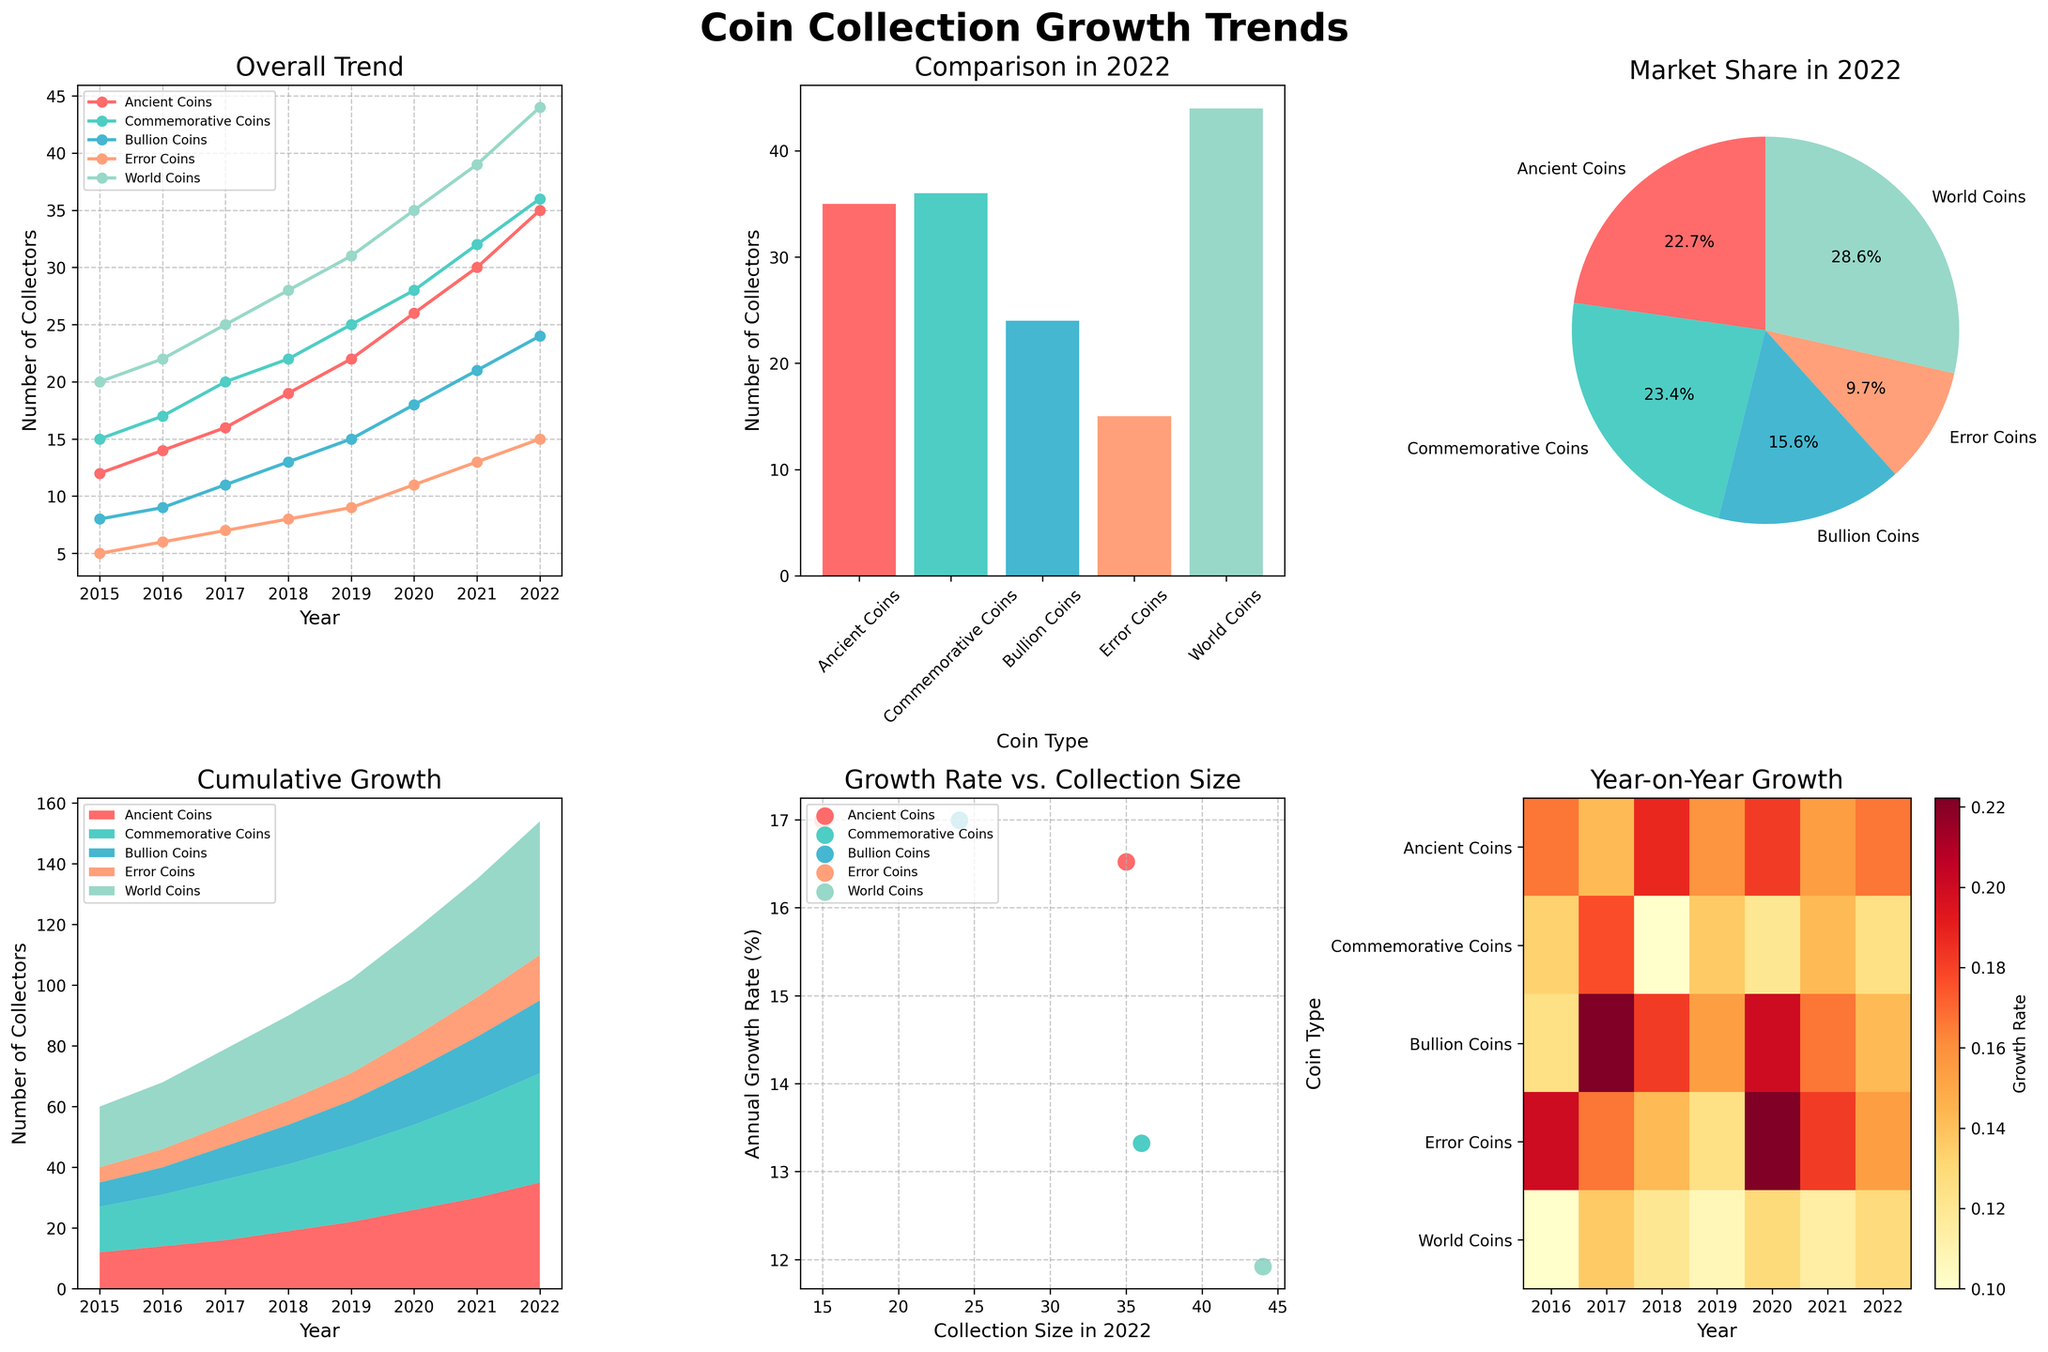What's the overall trend title in the figure? The title of the subplot can be gleaned from the text above the corresponding plot. Looking at the top-left corner, we see the title 'Overall Trend'.
Answer: Overall Trend How many collectors were there for Ancient Coins in 2020? To find the number of Ancient Coin collectors in 2020, locate the point representing the year 2020 on the x-axis and look for its corresponding y-value for the 'Ancient Coins' line, which is close to 26 according to the line plot.
Answer: 26 Which coin type had the highest number of collectors in 2022? The bar plot in the figure provides a clear comparison among the different coin types in 2022. The tallest bar represents 'World Coins', indicating it has the highest number of collectors.
Answer: World Coins Which coin type experienced the highest annual growth rate? The scatter plot compares collection size in 2022 with the annual growth rate. The highest point on the y-axis, indicating the highest growth rate, corresponds to 'World Coins'.
Answer: World Coins What is the color used to represent Bullion Coins in the line plot? The line for each coin type on the line plot has a unique color. The line representing Bullion Coins is in a shade of light blue.
Answer: Light blue How has the cumulative number of collectors changed for all coin types together from 2015 to 2022? The area plot shows the combined number of collectors over time for all coin types. It shows all areas growing together from 2015 to 2022, demonstrating a continuous increase.
Answer: Continuously increased Which year saw the highest year-on-year growth for Error Coins? In the heatmap subplot, locate the row for 'Error Coins' and identify the brightest square, which corresponds to the highest growth rate. This square is in the column labeled 2021.
Answer: 2021 What percentage of collectors in 2022 collected Ancient Coins? The pie chart segment labeled 'Ancient Coins' represents that coin type's share among all collectors in 2022. This segment is labeled '18.4%', indicating the percentage.
Answer: 18.4% Which coin type showed the least growth in the number of collectors between 2018 and 2020? Comparing the lengths of the individual segments along the respective years in the stacked area plot, 'Error Coins' shows the least increase between 2018 and 2020.
Answer: Error Coins 